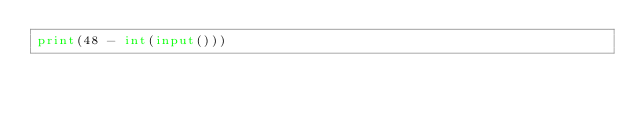Convert code to text. <code><loc_0><loc_0><loc_500><loc_500><_Python_>print(48 - int(input()))</code> 